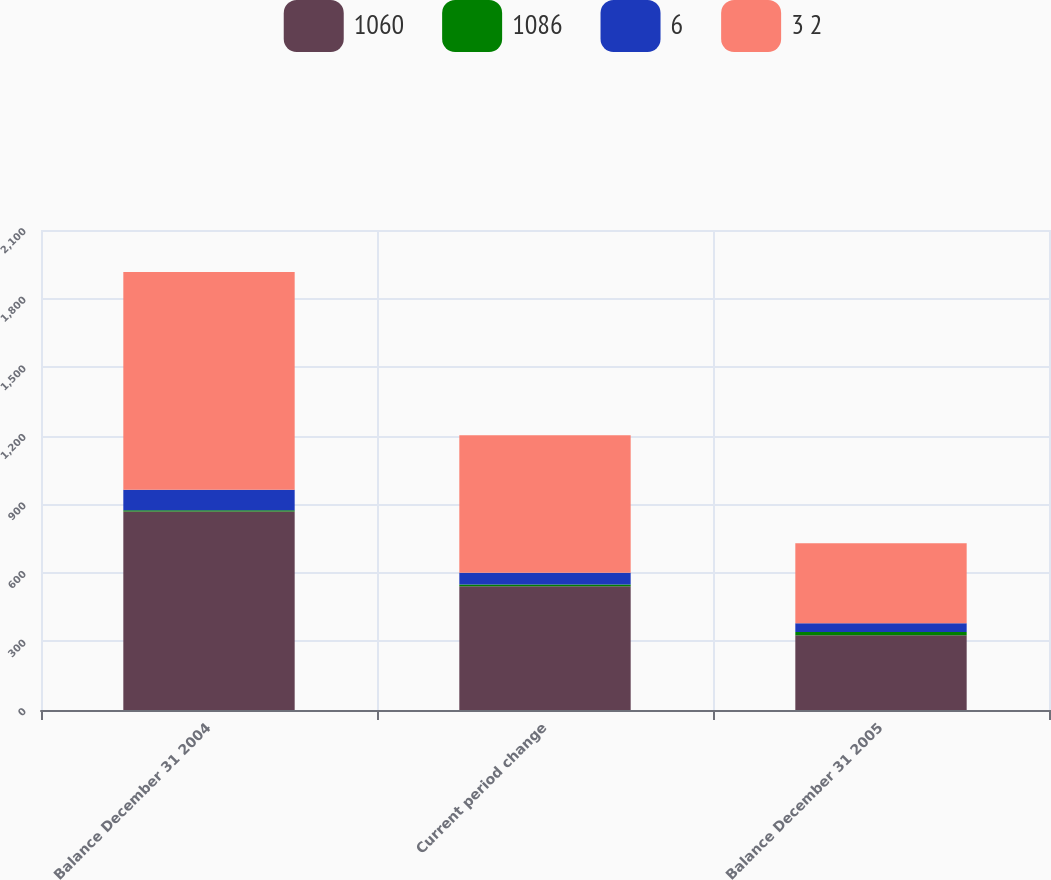<chart> <loc_0><loc_0><loc_500><loc_500><stacked_bar_chart><ecel><fcel>Balance December 31 2004<fcel>Current period change<fcel>Balance December 31 2005<nl><fcel>1060<fcel>868<fcel>541<fcel>327<nl><fcel>1086<fcel>6<fcel>8<fcel>14<nl><fcel>6<fcel>90<fcel>52<fcel>38<nl><fcel>3 2<fcel>952<fcel>601<fcel>351<nl></chart> 